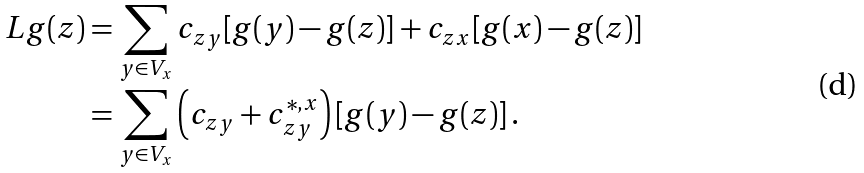Convert formula to latex. <formula><loc_0><loc_0><loc_500><loc_500>L g ( z ) & = \sum _ { y \in V _ { x } } c _ { z y } [ g ( y ) - g ( z ) ] + c _ { z x } [ g ( x ) - g ( z ) ] \\ & = \sum _ { y \in V _ { x } } \left ( c _ { z y } + c _ { z y } ^ { * , x } \right ) [ g ( y ) - g ( z ) ] \, .</formula> 